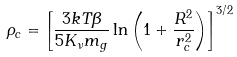Convert formula to latex. <formula><loc_0><loc_0><loc_500><loc_500>\rho _ { c } = \left [ \frac { 3 k T \beta } { 5 K _ { \nu } m _ { g } } \ln { \left ( 1 + \frac { R ^ { 2 } } { r _ { c } ^ { 2 } } \right ) } \right ] ^ { 3 / 2 }</formula> 